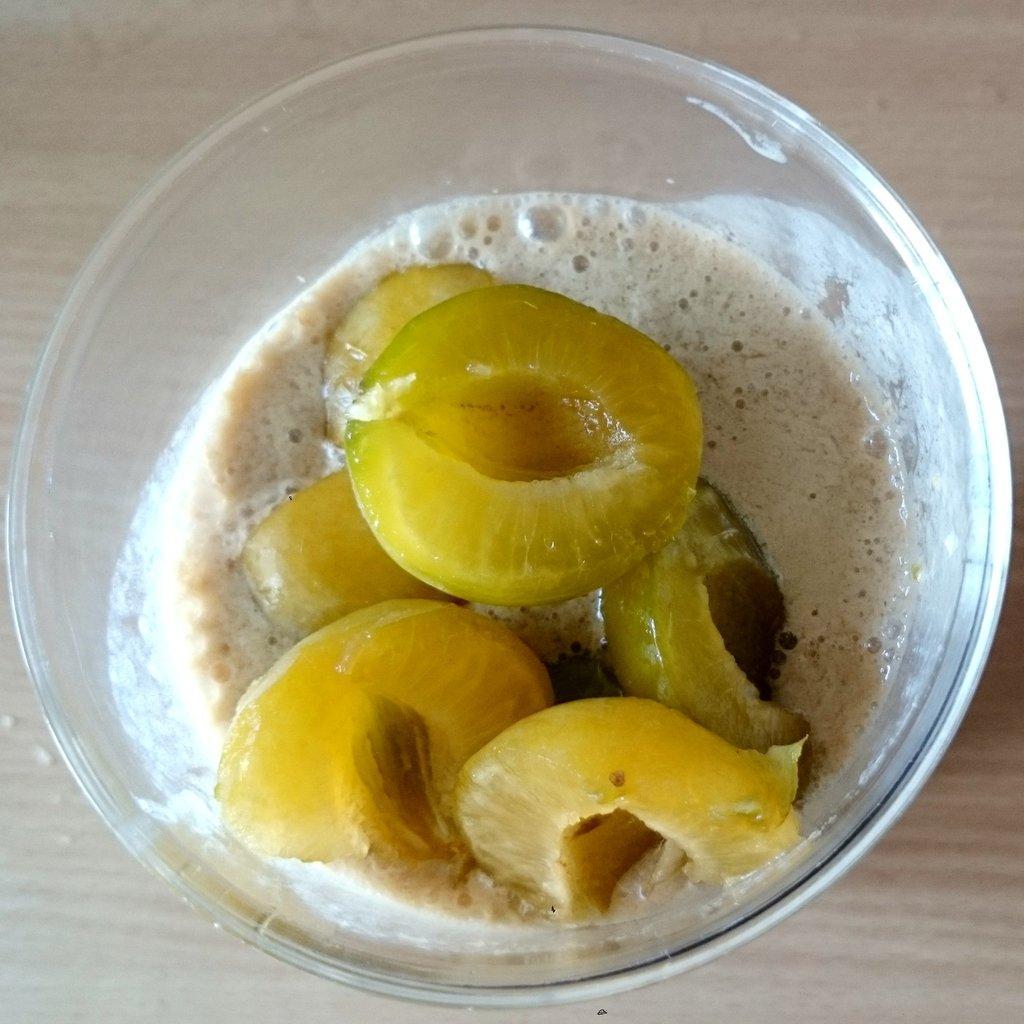In one or two sentences, can you explain what this image depicts? This is a zoomed in picture. In the center there is a bowl containing some food item and the bowl seems to be placed on the wooden object which seems to be the table. 